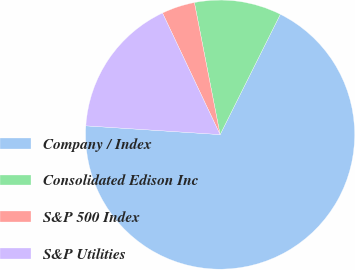Convert chart to OTSL. <chart><loc_0><loc_0><loc_500><loc_500><pie_chart><fcel>Company / Index<fcel>Consolidated Edison Inc<fcel>S&P 500 Index<fcel>S&P Utilities<nl><fcel>68.65%<fcel>10.45%<fcel>3.98%<fcel>16.92%<nl></chart> 